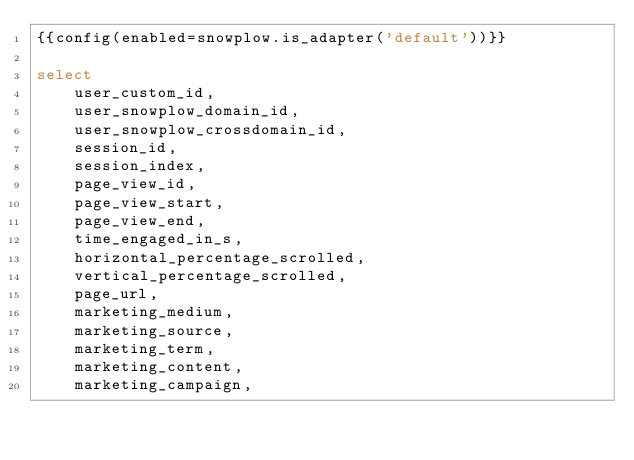<code> <loc_0><loc_0><loc_500><loc_500><_SQL_>{{config(enabled=snowplow.is_adapter('default'))}}

select
    user_custom_id,
    user_snowplow_domain_id,
    user_snowplow_crossdomain_id,
    session_id,
    session_index,
    page_view_id,
    page_view_start,
    page_view_end,
    time_engaged_in_s,
    horizontal_percentage_scrolled,
    vertical_percentage_scrolled,
    page_url,
    marketing_medium,
    marketing_source,
    marketing_term,
    marketing_content,
    marketing_campaign,</code> 